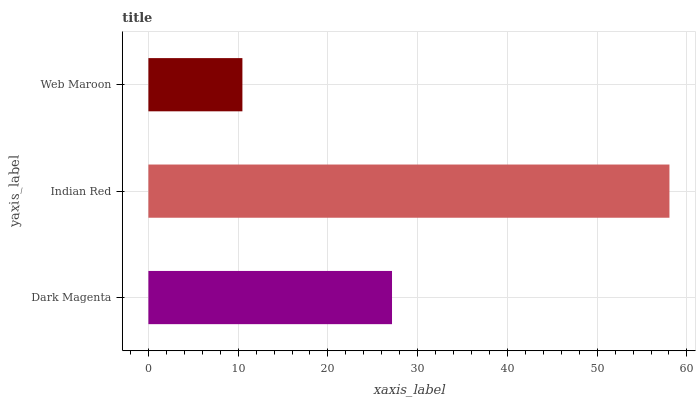Is Web Maroon the minimum?
Answer yes or no. Yes. Is Indian Red the maximum?
Answer yes or no. Yes. Is Indian Red the minimum?
Answer yes or no. No. Is Web Maroon the maximum?
Answer yes or no. No. Is Indian Red greater than Web Maroon?
Answer yes or no. Yes. Is Web Maroon less than Indian Red?
Answer yes or no. Yes. Is Web Maroon greater than Indian Red?
Answer yes or no. No. Is Indian Red less than Web Maroon?
Answer yes or no. No. Is Dark Magenta the high median?
Answer yes or no. Yes. Is Dark Magenta the low median?
Answer yes or no. Yes. Is Indian Red the high median?
Answer yes or no. No. Is Indian Red the low median?
Answer yes or no. No. 